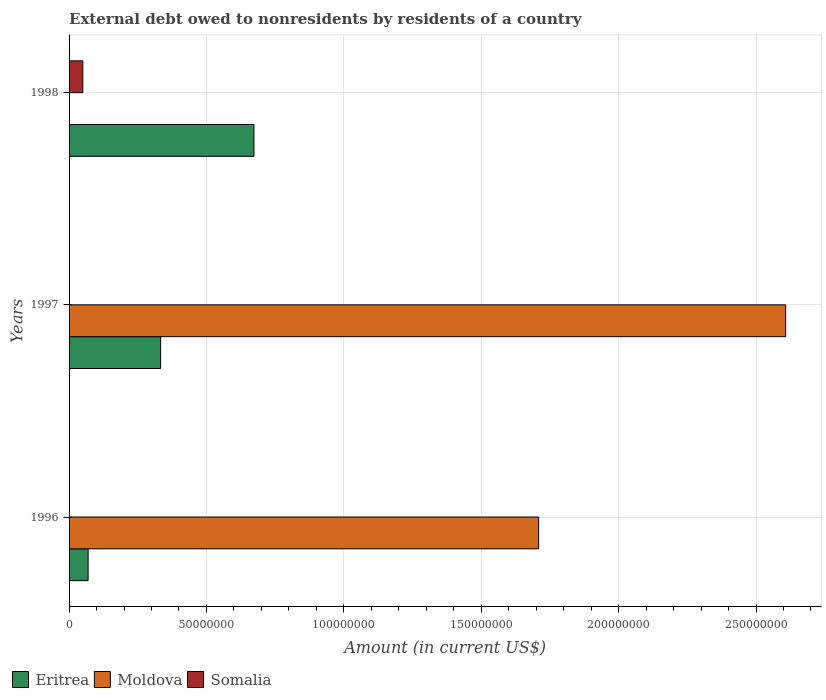How many groups of bars are there?
Ensure brevity in your answer.  3. Are the number of bars per tick equal to the number of legend labels?
Provide a succinct answer. No. How many bars are there on the 1st tick from the top?
Your answer should be very brief. 2. How many bars are there on the 1st tick from the bottom?
Give a very brief answer. 3. In how many cases, is the number of bars for a given year not equal to the number of legend labels?
Provide a short and direct response. 2. What is the external debt owed by residents in Eritrea in 1998?
Offer a very short reply. 6.73e+07. Across all years, what is the maximum external debt owed by residents in Eritrea?
Your response must be concise. 6.73e+07. Across all years, what is the minimum external debt owed by residents in Moldova?
Offer a very short reply. 0. What is the total external debt owed by residents in Somalia in the graph?
Offer a terse response. 5.00e+06. What is the difference between the external debt owed by residents in Eritrea in 1997 and that in 1998?
Provide a short and direct response. -3.40e+07. What is the difference between the external debt owed by residents in Somalia in 1997 and the external debt owed by residents in Moldova in 1998?
Keep it short and to the point. 0. What is the average external debt owed by residents in Moldova per year?
Your answer should be compact. 1.44e+08. In the year 1996, what is the difference between the external debt owed by residents in Moldova and external debt owed by residents in Eritrea?
Your answer should be very brief. 1.64e+08. In how many years, is the external debt owed by residents in Eritrea greater than 120000000 US$?
Your answer should be compact. 0. Is the external debt owed by residents in Somalia in 1996 less than that in 1998?
Your response must be concise. Yes. What is the difference between the highest and the second highest external debt owed by residents in Eritrea?
Make the answer very short. 3.40e+07. What is the difference between the highest and the lowest external debt owed by residents in Somalia?
Ensure brevity in your answer.  5.00e+06. In how many years, is the external debt owed by residents in Moldova greater than the average external debt owed by residents in Moldova taken over all years?
Ensure brevity in your answer.  2. Is it the case that in every year, the sum of the external debt owed by residents in Moldova and external debt owed by residents in Eritrea is greater than the external debt owed by residents in Somalia?
Your answer should be very brief. Yes. How many bars are there?
Keep it short and to the point. 7. Does the graph contain any zero values?
Your answer should be compact. Yes. Where does the legend appear in the graph?
Provide a short and direct response. Bottom left. How many legend labels are there?
Ensure brevity in your answer.  3. What is the title of the graph?
Keep it short and to the point. External debt owed to nonresidents by residents of a country. What is the label or title of the X-axis?
Keep it short and to the point. Amount (in current US$). What is the label or title of the Y-axis?
Offer a very short reply. Years. What is the Amount (in current US$) of Eritrea in 1996?
Provide a succinct answer. 6.93e+06. What is the Amount (in current US$) in Moldova in 1996?
Provide a succinct answer. 1.71e+08. What is the Amount (in current US$) of Somalia in 1996?
Your answer should be compact. 1000. What is the Amount (in current US$) in Eritrea in 1997?
Give a very brief answer. 3.33e+07. What is the Amount (in current US$) of Moldova in 1997?
Keep it short and to the point. 2.61e+08. What is the Amount (in current US$) of Eritrea in 1998?
Your answer should be very brief. 6.73e+07. Across all years, what is the maximum Amount (in current US$) of Eritrea?
Give a very brief answer. 6.73e+07. Across all years, what is the maximum Amount (in current US$) of Moldova?
Your response must be concise. 2.61e+08. Across all years, what is the minimum Amount (in current US$) of Eritrea?
Ensure brevity in your answer.  6.93e+06. Across all years, what is the minimum Amount (in current US$) of Moldova?
Keep it short and to the point. 0. Across all years, what is the minimum Amount (in current US$) of Somalia?
Your answer should be very brief. 0. What is the total Amount (in current US$) in Eritrea in the graph?
Your response must be concise. 1.08e+08. What is the total Amount (in current US$) in Moldova in the graph?
Keep it short and to the point. 4.32e+08. What is the total Amount (in current US$) in Somalia in the graph?
Offer a terse response. 5.00e+06. What is the difference between the Amount (in current US$) of Eritrea in 1996 and that in 1997?
Your response must be concise. -2.64e+07. What is the difference between the Amount (in current US$) in Moldova in 1996 and that in 1997?
Offer a very short reply. -8.99e+07. What is the difference between the Amount (in current US$) in Eritrea in 1996 and that in 1998?
Give a very brief answer. -6.03e+07. What is the difference between the Amount (in current US$) of Somalia in 1996 and that in 1998?
Your answer should be very brief. -5.00e+06. What is the difference between the Amount (in current US$) of Eritrea in 1997 and that in 1998?
Keep it short and to the point. -3.40e+07. What is the difference between the Amount (in current US$) in Eritrea in 1996 and the Amount (in current US$) in Moldova in 1997?
Give a very brief answer. -2.54e+08. What is the difference between the Amount (in current US$) of Eritrea in 1996 and the Amount (in current US$) of Somalia in 1998?
Provide a short and direct response. 1.93e+06. What is the difference between the Amount (in current US$) in Moldova in 1996 and the Amount (in current US$) in Somalia in 1998?
Ensure brevity in your answer.  1.66e+08. What is the difference between the Amount (in current US$) of Eritrea in 1997 and the Amount (in current US$) of Somalia in 1998?
Your response must be concise. 2.83e+07. What is the difference between the Amount (in current US$) in Moldova in 1997 and the Amount (in current US$) in Somalia in 1998?
Make the answer very short. 2.56e+08. What is the average Amount (in current US$) of Eritrea per year?
Provide a succinct answer. 3.58e+07. What is the average Amount (in current US$) in Moldova per year?
Provide a succinct answer. 1.44e+08. What is the average Amount (in current US$) in Somalia per year?
Your response must be concise. 1.67e+06. In the year 1996, what is the difference between the Amount (in current US$) in Eritrea and Amount (in current US$) in Moldova?
Give a very brief answer. -1.64e+08. In the year 1996, what is the difference between the Amount (in current US$) in Eritrea and Amount (in current US$) in Somalia?
Ensure brevity in your answer.  6.93e+06. In the year 1996, what is the difference between the Amount (in current US$) in Moldova and Amount (in current US$) in Somalia?
Your answer should be very brief. 1.71e+08. In the year 1997, what is the difference between the Amount (in current US$) in Eritrea and Amount (in current US$) in Moldova?
Your answer should be very brief. -2.27e+08. In the year 1998, what is the difference between the Amount (in current US$) of Eritrea and Amount (in current US$) of Somalia?
Make the answer very short. 6.23e+07. What is the ratio of the Amount (in current US$) of Eritrea in 1996 to that in 1997?
Your answer should be very brief. 0.21. What is the ratio of the Amount (in current US$) in Moldova in 1996 to that in 1997?
Your response must be concise. 0.66. What is the ratio of the Amount (in current US$) in Eritrea in 1996 to that in 1998?
Offer a terse response. 0.1. What is the ratio of the Amount (in current US$) in Somalia in 1996 to that in 1998?
Offer a very short reply. 0. What is the ratio of the Amount (in current US$) in Eritrea in 1997 to that in 1998?
Your response must be concise. 0.5. What is the difference between the highest and the second highest Amount (in current US$) of Eritrea?
Make the answer very short. 3.40e+07. What is the difference between the highest and the lowest Amount (in current US$) in Eritrea?
Keep it short and to the point. 6.03e+07. What is the difference between the highest and the lowest Amount (in current US$) of Moldova?
Keep it short and to the point. 2.61e+08. 